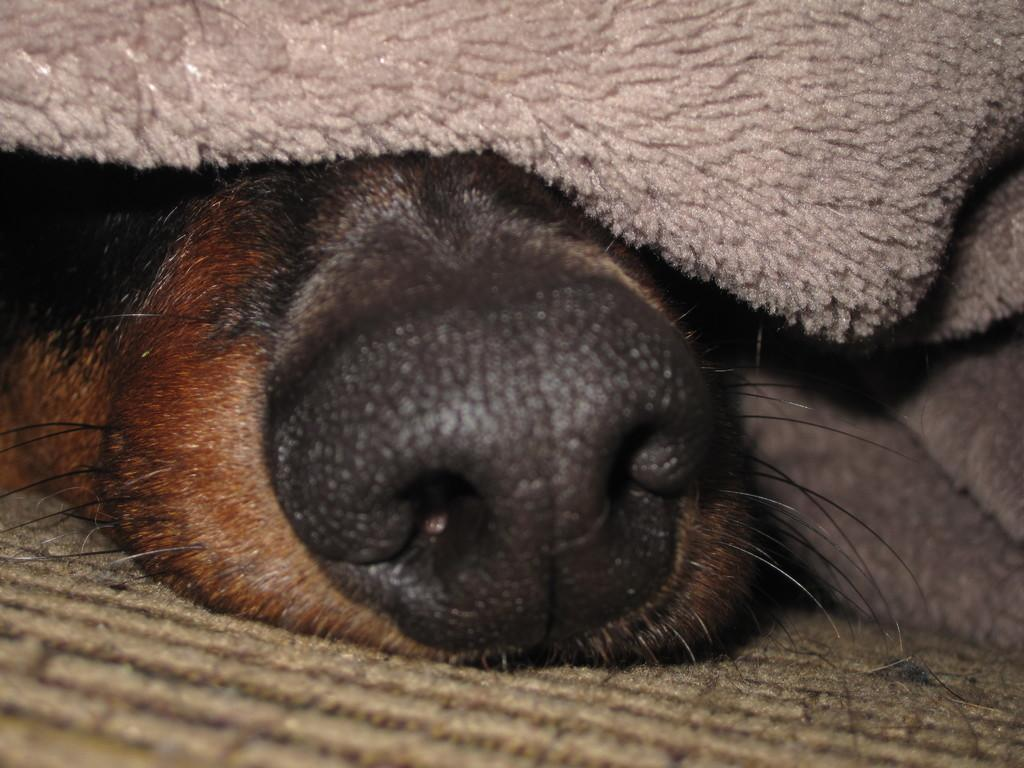What part of a dog is visible in the image? There is a dog's nose in the image. Where is the dog's nose located in relation to other objects? The dog's nose is under a blanket. Can you see a snake slithering near the dog's nose in the image? No, there is no snake present in the image. 